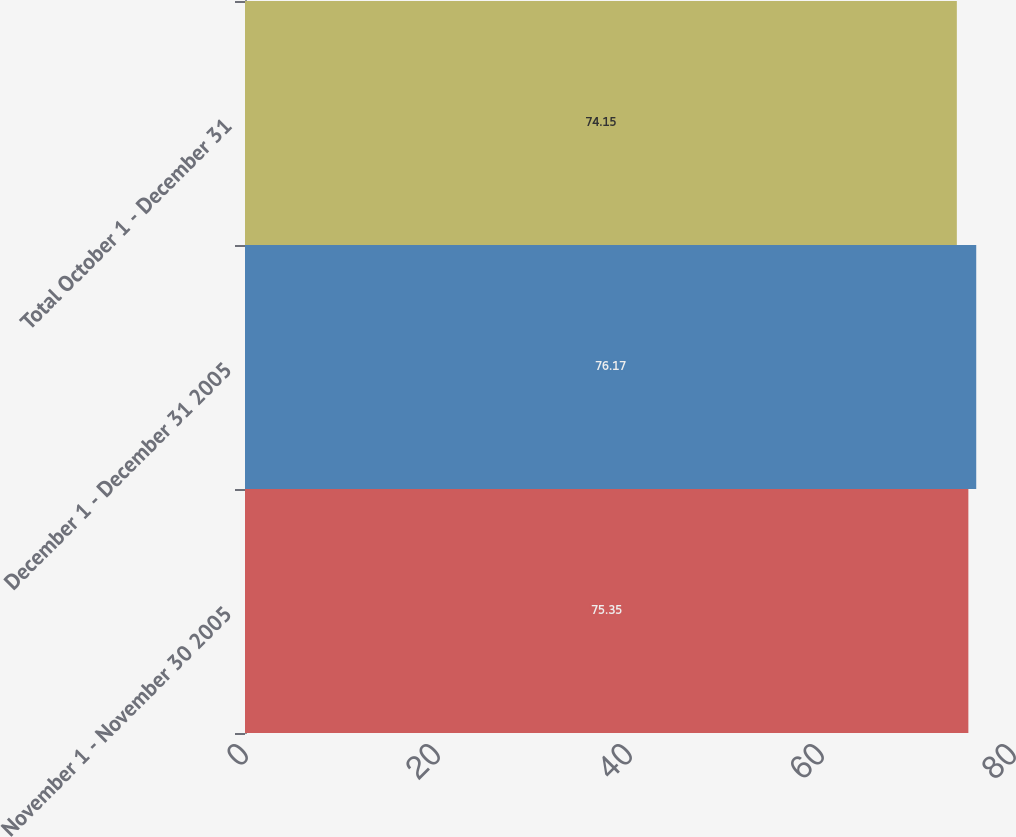Convert chart to OTSL. <chart><loc_0><loc_0><loc_500><loc_500><bar_chart><fcel>November 1 - November 30 2005<fcel>December 1 - December 31 2005<fcel>Total October 1 - December 31<nl><fcel>75.35<fcel>76.17<fcel>74.15<nl></chart> 